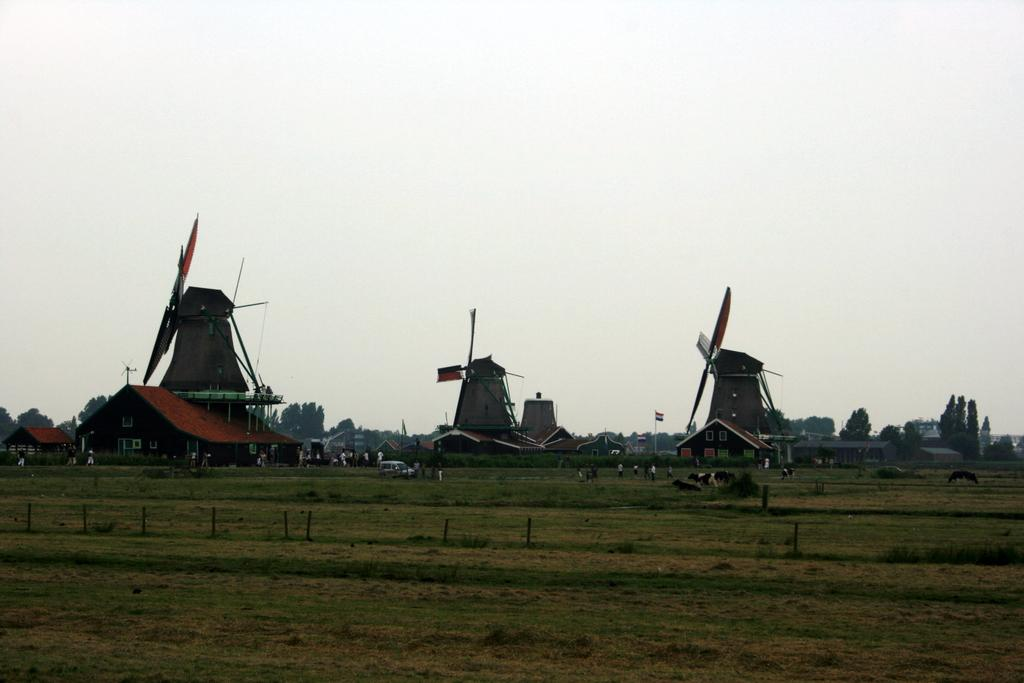What is the main surface visible in the image? There is a ground in the image. What can be seen on the ground? There are persons and houses on the ground. What structure is present in the image besides the houses? There is a tower in the image. What makes the tower unique in the image? The tower has wings attached to it. What is visible at the top of the image? The sky is visible at the top of the image. Can you tell me how many carts are parked near the tower in the image? There is no cart present in the image; it only features a ground, houses, persons, a tower with wings, and the sky. What type of teeth can be seen on the persons in the image? There is no indication of teeth in the image, as it only shows a ground, houses, persons, a tower with wings, and the sky. 